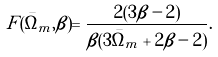<formula> <loc_0><loc_0><loc_500><loc_500>F ( \bar { \Omega } _ { m } , \beta ) = \frac { 2 ( 3 \beta - 2 ) } { \beta ( 3 { \bar { \Omega } } _ { m } + 2 \beta - 2 ) } .</formula> 